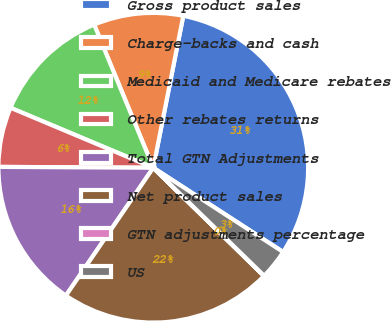<chart> <loc_0><loc_0><loc_500><loc_500><pie_chart><fcel>Gross product sales<fcel>Charge-backs and cash<fcel>Medicaid and Medicare rebates<fcel>Other rebates returns<fcel>Total GTN Adjustments<fcel>Net product sales<fcel>GTN adjustments percentage<fcel>US<nl><fcel>31.06%<fcel>9.34%<fcel>12.44%<fcel>6.24%<fcel>15.55%<fcel>22.22%<fcel>0.03%<fcel>3.13%<nl></chart> 